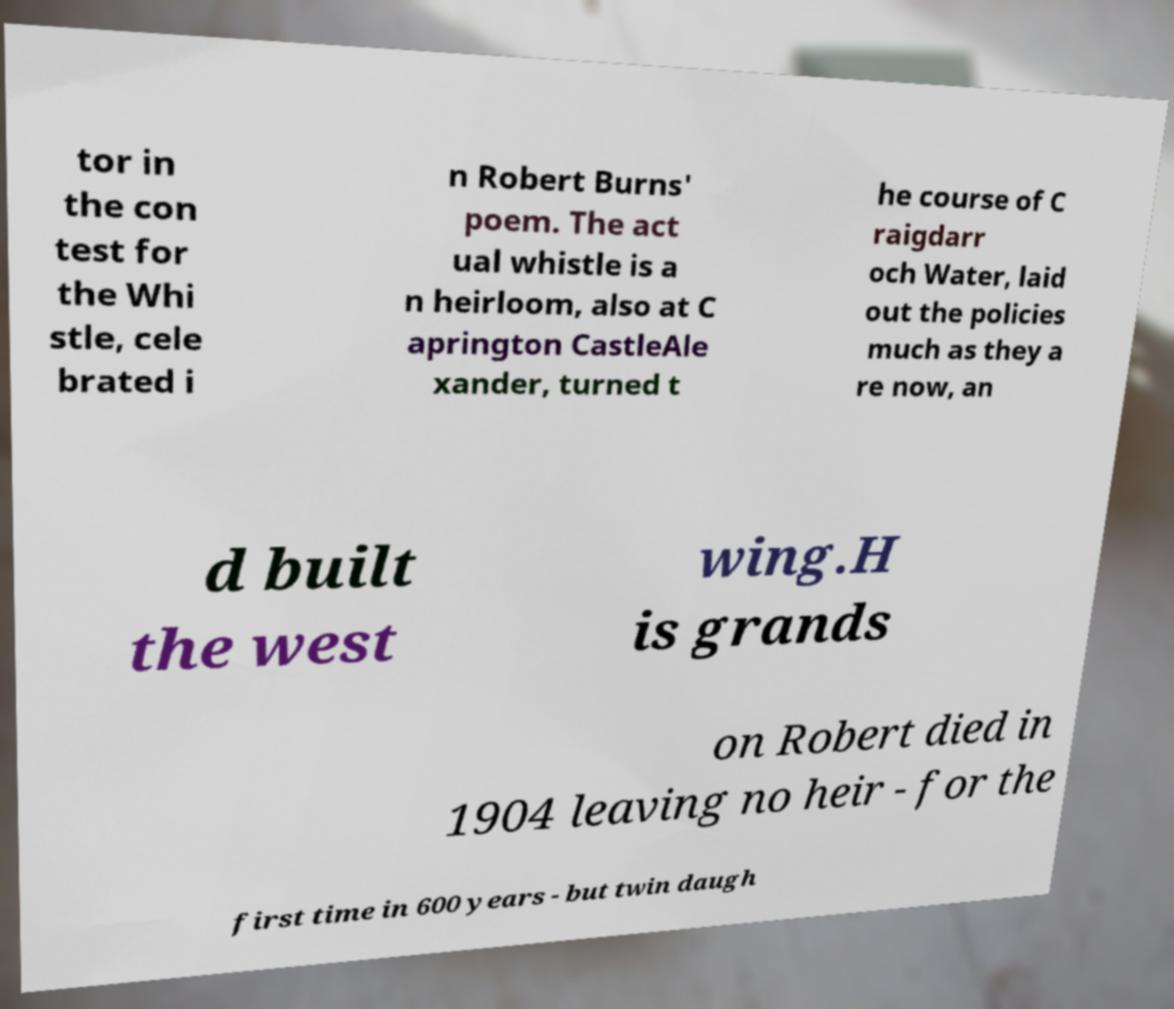I need the written content from this picture converted into text. Can you do that? tor in the con test for the Whi stle, cele brated i n Robert Burns' poem. The act ual whistle is a n heirloom, also at C aprington CastleAle xander, turned t he course of C raigdarr och Water, laid out the policies much as they a re now, an d built the west wing.H is grands on Robert died in 1904 leaving no heir - for the first time in 600 years - but twin daugh 